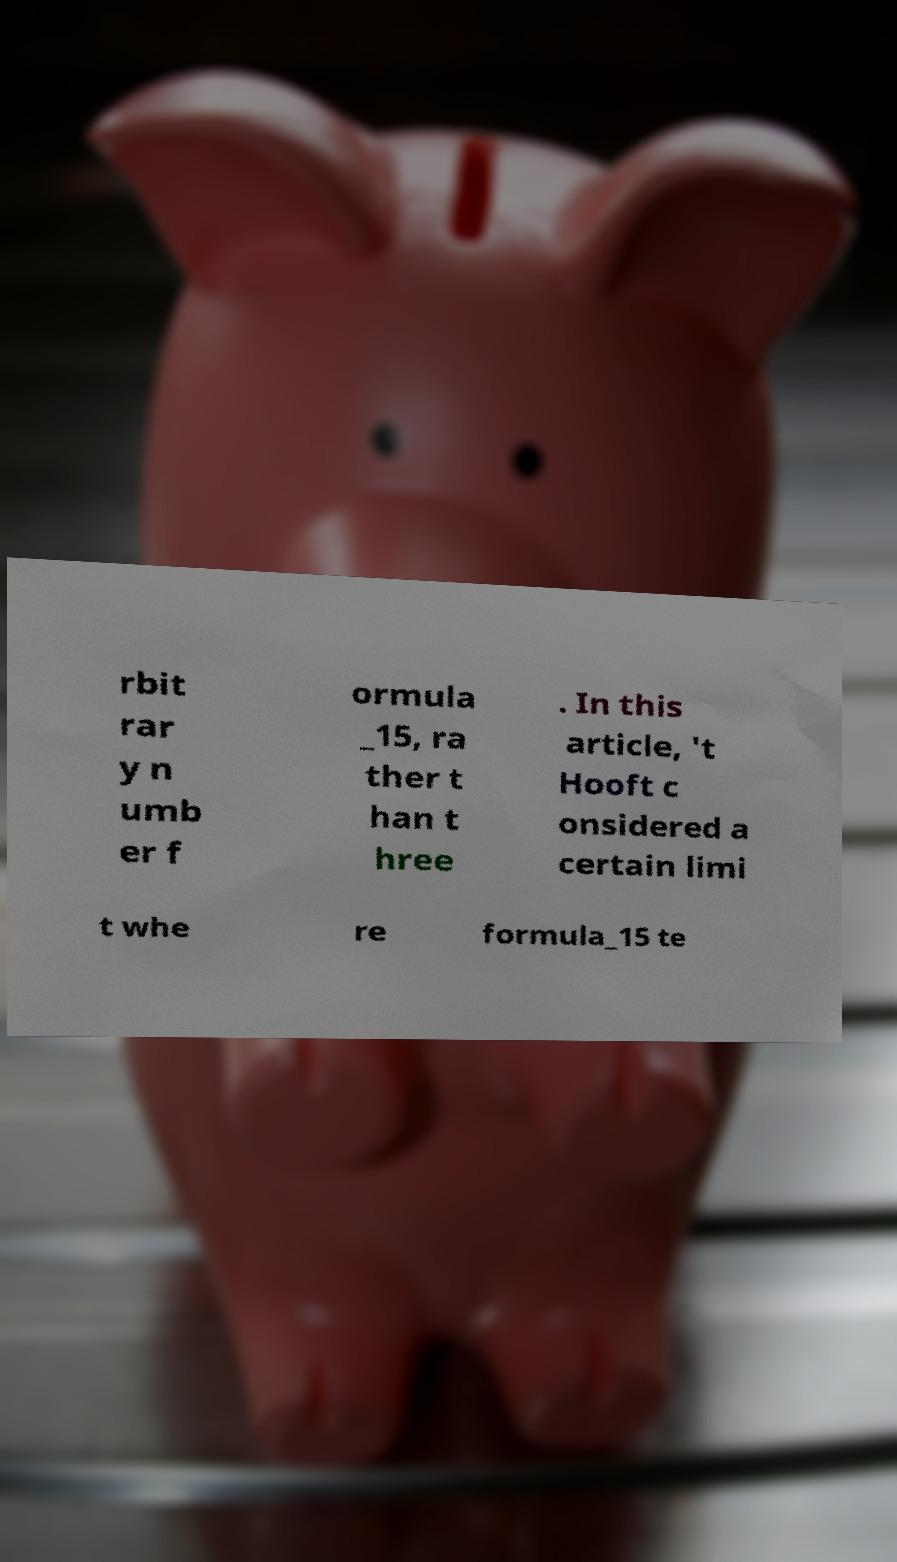Please read and relay the text visible in this image. What does it say? rbit rar y n umb er f ormula _15, ra ther t han t hree . In this article, 't Hooft c onsidered a certain limi t whe re formula_15 te 